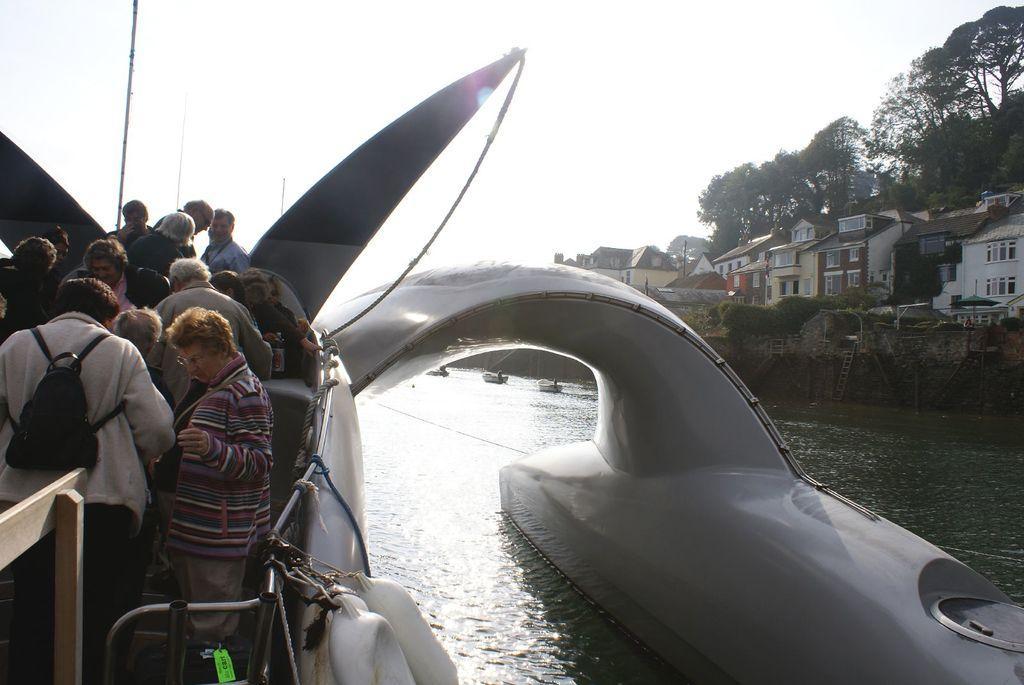In one or two sentences, can you explain what this image depicts? In the image there is a boat on the water. On the left side of the image there are few people in the boat. And also there are railings, ropes and tubes. And also there is a wooden object. Behind that there are three more boats on the water. Behind them there is a wall with ladders. And also there are houses with walls, roofs and windows. Behind them there are trees. At the top of the image there is sky. 